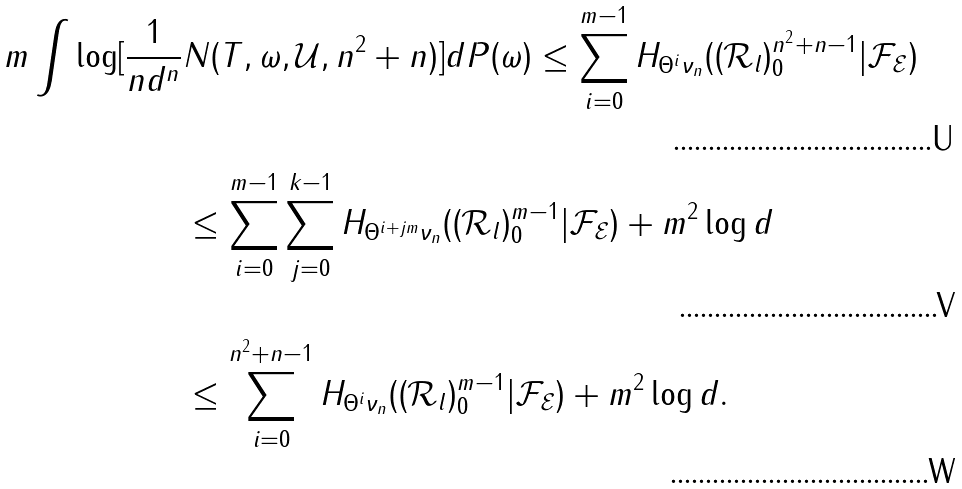<formula> <loc_0><loc_0><loc_500><loc_500>m \int \log [ \frac { 1 } { n d ^ { n } } & N ( T , \omega , \mathcal { U } , n ^ { 2 } + n ) ] d P ( \omega ) \leq \sum _ { i = 0 } ^ { m - 1 } H _ { \Theta ^ { i } \nu _ { n } } ( ( \mathcal { R } _ { l } ) _ { 0 } ^ { n ^ { 2 } + n - 1 } | \mathcal { F } _ { \mathcal { E } } ) \\ & \leq \sum _ { i = 0 } ^ { m - 1 } \sum _ { j = 0 } ^ { k - 1 } H _ { \Theta ^ { i + j m } \nu _ { n } } ( ( \mathcal { R } _ { l } ) _ { 0 } ^ { m - 1 } | \mathcal { F } _ { \mathcal { E } } ) + m ^ { 2 } \log d \\ & \leq \sum _ { i = 0 } ^ { n ^ { 2 } + n - 1 } H _ { \Theta ^ { i } \nu _ { n } } ( ( \mathcal { R } _ { l } ) _ { 0 } ^ { m - 1 } | \mathcal { F } _ { \mathcal { E } } ) + m ^ { 2 } \log d .</formula> 